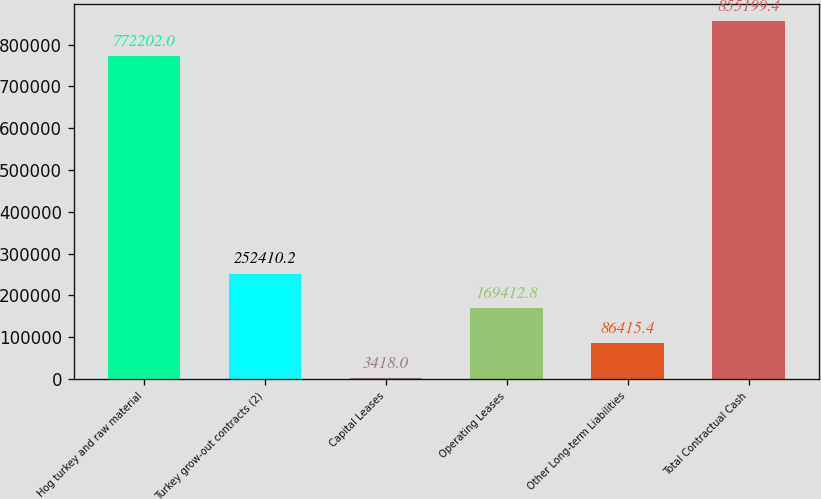Convert chart. <chart><loc_0><loc_0><loc_500><loc_500><bar_chart><fcel>Hog turkey and raw material<fcel>Turkey grow-out contracts (2)<fcel>Capital Leases<fcel>Operating Leases<fcel>Other Long-term Liabilities<fcel>Total Contractual Cash<nl><fcel>772202<fcel>252410<fcel>3418<fcel>169413<fcel>86415.4<fcel>855199<nl></chart> 